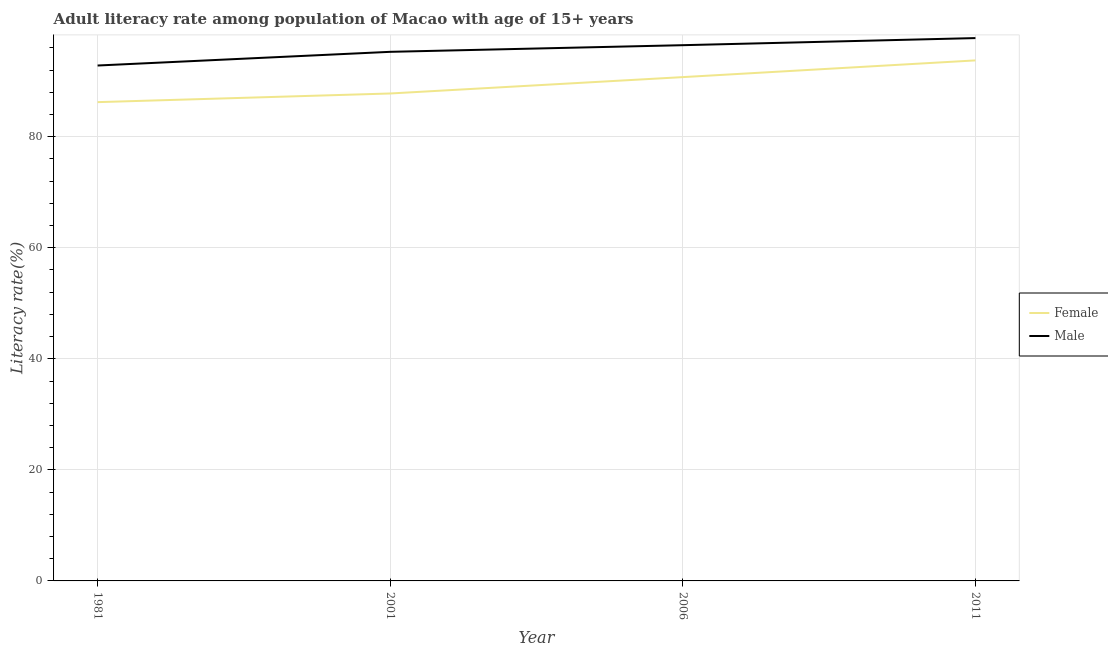How many different coloured lines are there?
Keep it short and to the point. 2. Does the line corresponding to female adult literacy rate intersect with the line corresponding to male adult literacy rate?
Give a very brief answer. No. Is the number of lines equal to the number of legend labels?
Your answer should be very brief. Yes. What is the female adult literacy rate in 1981?
Ensure brevity in your answer.  86.22. Across all years, what is the maximum female adult literacy rate?
Make the answer very short. 93.73. Across all years, what is the minimum male adult literacy rate?
Your answer should be compact. 92.81. In which year was the female adult literacy rate maximum?
Provide a short and direct response. 2011. In which year was the male adult literacy rate minimum?
Your response must be concise. 1981. What is the total female adult literacy rate in the graph?
Provide a short and direct response. 358.45. What is the difference between the female adult literacy rate in 2006 and that in 2011?
Provide a succinct answer. -3.01. What is the difference between the female adult literacy rate in 2011 and the male adult literacy rate in 2006?
Your answer should be compact. -2.74. What is the average male adult literacy rate per year?
Provide a short and direct response. 95.58. In the year 1981, what is the difference between the female adult literacy rate and male adult literacy rate?
Provide a short and direct response. -6.59. What is the ratio of the male adult literacy rate in 2001 to that in 2006?
Offer a very short reply. 0.99. What is the difference between the highest and the second highest male adult literacy rate?
Ensure brevity in your answer.  1.28. What is the difference between the highest and the lowest male adult literacy rate?
Make the answer very short. 4.94. Is the sum of the male adult literacy rate in 2006 and 2011 greater than the maximum female adult literacy rate across all years?
Keep it short and to the point. Yes. Does the male adult literacy rate monotonically increase over the years?
Provide a succinct answer. Yes. Is the male adult literacy rate strictly less than the female adult literacy rate over the years?
Offer a terse response. No. How many lines are there?
Offer a terse response. 2. What is the difference between two consecutive major ticks on the Y-axis?
Offer a terse response. 20. Are the values on the major ticks of Y-axis written in scientific E-notation?
Ensure brevity in your answer.  No. Does the graph contain any zero values?
Make the answer very short. No. How many legend labels are there?
Provide a short and direct response. 2. How are the legend labels stacked?
Give a very brief answer. Vertical. What is the title of the graph?
Give a very brief answer. Adult literacy rate among population of Macao with age of 15+ years. Does "Nonresident" appear as one of the legend labels in the graph?
Offer a terse response. No. What is the label or title of the X-axis?
Provide a short and direct response. Year. What is the label or title of the Y-axis?
Your answer should be compact. Literacy rate(%). What is the Literacy rate(%) of Female in 1981?
Your answer should be compact. 86.22. What is the Literacy rate(%) in Male in 1981?
Your answer should be very brief. 92.81. What is the Literacy rate(%) of Female in 2001?
Your answer should be compact. 87.77. What is the Literacy rate(%) of Male in 2001?
Keep it short and to the point. 95.28. What is the Literacy rate(%) in Female in 2006?
Your answer should be very brief. 90.72. What is the Literacy rate(%) of Male in 2006?
Keep it short and to the point. 96.47. What is the Literacy rate(%) of Female in 2011?
Provide a short and direct response. 93.73. What is the Literacy rate(%) of Male in 2011?
Your answer should be compact. 97.75. Across all years, what is the maximum Literacy rate(%) of Female?
Your answer should be compact. 93.73. Across all years, what is the maximum Literacy rate(%) of Male?
Provide a succinct answer. 97.75. Across all years, what is the minimum Literacy rate(%) in Female?
Keep it short and to the point. 86.22. Across all years, what is the minimum Literacy rate(%) in Male?
Provide a succinct answer. 92.81. What is the total Literacy rate(%) of Female in the graph?
Your answer should be very brief. 358.45. What is the total Literacy rate(%) of Male in the graph?
Your response must be concise. 382.31. What is the difference between the Literacy rate(%) in Female in 1981 and that in 2001?
Ensure brevity in your answer.  -1.56. What is the difference between the Literacy rate(%) in Male in 1981 and that in 2001?
Your answer should be very brief. -2.47. What is the difference between the Literacy rate(%) in Female in 1981 and that in 2006?
Offer a terse response. -4.51. What is the difference between the Literacy rate(%) in Male in 1981 and that in 2006?
Your response must be concise. -3.66. What is the difference between the Literacy rate(%) in Female in 1981 and that in 2011?
Your answer should be compact. -7.52. What is the difference between the Literacy rate(%) in Male in 1981 and that in 2011?
Offer a very short reply. -4.94. What is the difference between the Literacy rate(%) of Female in 2001 and that in 2006?
Give a very brief answer. -2.95. What is the difference between the Literacy rate(%) in Male in 2001 and that in 2006?
Your answer should be very brief. -1.19. What is the difference between the Literacy rate(%) in Female in 2001 and that in 2011?
Provide a short and direct response. -5.96. What is the difference between the Literacy rate(%) of Male in 2001 and that in 2011?
Your answer should be compact. -2.48. What is the difference between the Literacy rate(%) in Female in 2006 and that in 2011?
Provide a short and direct response. -3.01. What is the difference between the Literacy rate(%) in Male in 2006 and that in 2011?
Provide a short and direct response. -1.28. What is the difference between the Literacy rate(%) of Female in 1981 and the Literacy rate(%) of Male in 2001?
Ensure brevity in your answer.  -9.06. What is the difference between the Literacy rate(%) of Female in 1981 and the Literacy rate(%) of Male in 2006?
Keep it short and to the point. -10.25. What is the difference between the Literacy rate(%) in Female in 1981 and the Literacy rate(%) in Male in 2011?
Make the answer very short. -11.54. What is the difference between the Literacy rate(%) of Female in 2001 and the Literacy rate(%) of Male in 2006?
Ensure brevity in your answer.  -8.7. What is the difference between the Literacy rate(%) in Female in 2001 and the Literacy rate(%) in Male in 2011?
Your answer should be compact. -9.98. What is the difference between the Literacy rate(%) in Female in 2006 and the Literacy rate(%) in Male in 2011?
Offer a terse response. -7.03. What is the average Literacy rate(%) in Female per year?
Offer a very short reply. 89.61. What is the average Literacy rate(%) in Male per year?
Your response must be concise. 95.58. In the year 1981, what is the difference between the Literacy rate(%) in Female and Literacy rate(%) in Male?
Give a very brief answer. -6.59. In the year 2001, what is the difference between the Literacy rate(%) of Female and Literacy rate(%) of Male?
Ensure brevity in your answer.  -7.5. In the year 2006, what is the difference between the Literacy rate(%) in Female and Literacy rate(%) in Male?
Your answer should be compact. -5.75. In the year 2011, what is the difference between the Literacy rate(%) in Female and Literacy rate(%) in Male?
Offer a terse response. -4.02. What is the ratio of the Literacy rate(%) in Female in 1981 to that in 2001?
Your answer should be compact. 0.98. What is the ratio of the Literacy rate(%) of Male in 1981 to that in 2001?
Your answer should be compact. 0.97. What is the ratio of the Literacy rate(%) in Female in 1981 to that in 2006?
Your answer should be compact. 0.95. What is the ratio of the Literacy rate(%) of Male in 1981 to that in 2006?
Ensure brevity in your answer.  0.96. What is the ratio of the Literacy rate(%) in Female in 1981 to that in 2011?
Offer a terse response. 0.92. What is the ratio of the Literacy rate(%) in Male in 1981 to that in 2011?
Your response must be concise. 0.95. What is the ratio of the Literacy rate(%) of Female in 2001 to that in 2006?
Ensure brevity in your answer.  0.97. What is the ratio of the Literacy rate(%) of Male in 2001 to that in 2006?
Provide a succinct answer. 0.99. What is the ratio of the Literacy rate(%) in Female in 2001 to that in 2011?
Make the answer very short. 0.94. What is the ratio of the Literacy rate(%) of Male in 2001 to that in 2011?
Offer a very short reply. 0.97. What is the ratio of the Literacy rate(%) of Female in 2006 to that in 2011?
Make the answer very short. 0.97. What is the ratio of the Literacy rate(%) in Male in 2006 to that in 2011?
Make the answer very short. 0.99. What is the difference between the highest and the second highest Literacy rate(%) in Female?
Ensure brevity in your answer.  3.01. What is the difference between the highest and the second highest Literacy rate(%) in Male?
Provide a short and direct response. 1.28. What is the difference between the highest and the lowest Literacy rate(%) in Female?
Offer a very short reply. 7.52. What is the difference between the highest and the lowest Literacy rate(%) in Male?
Keep it short and to the point. 4.94. 